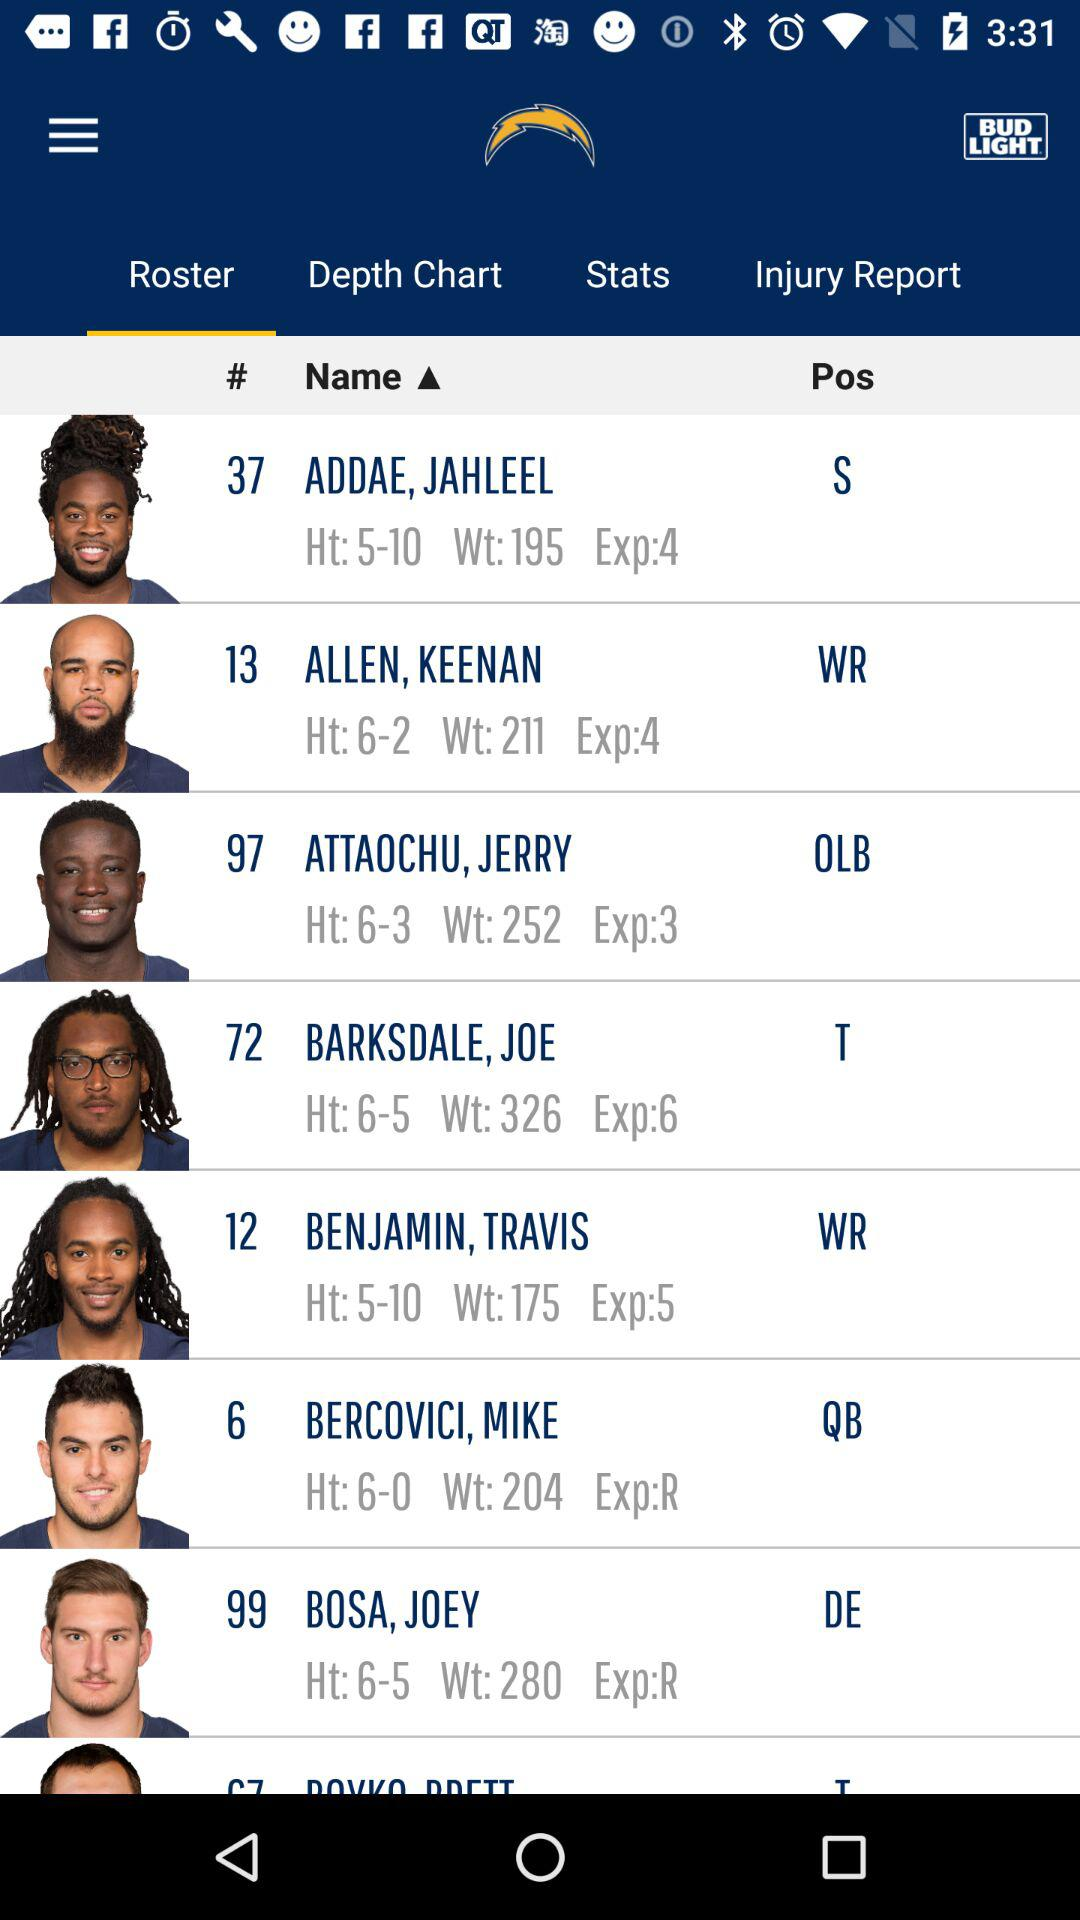What is the height of Joe Barksdale? The height is 6 feet 5 inches. 